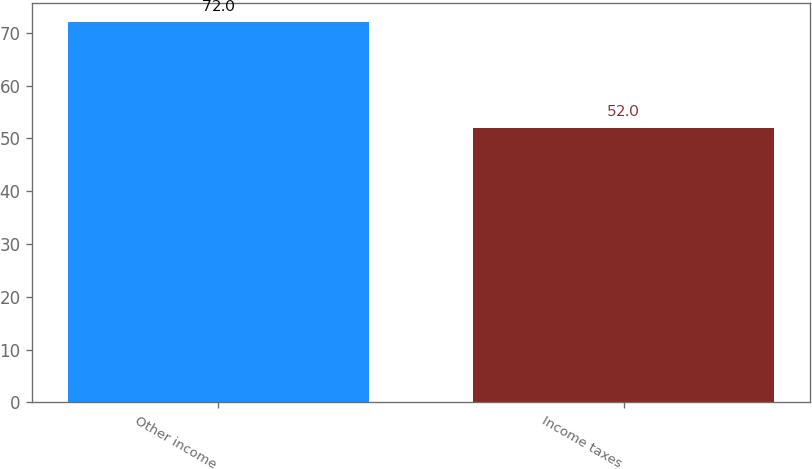Convert chart to OTSL. <chart><loc_0><loc_0><loc_500><loc_500><bar_chart><fcel>Other income<fcel>Income taxes<nl><fcel>72<fcel>52<nl></chart> 